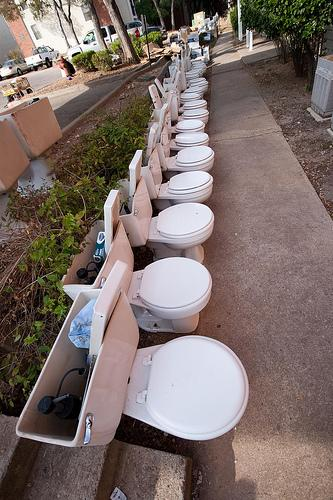Describe the image with the inclusion of specific details of the toilet setup. There are four toilets placed in a row with their seat covers down on a concrete surface, and the image showcases the plumbing, water tanks, and flush handles for each of the toilets. Express the content of the image, focusing on the positioning and intra-object relationships. Toilets with shut seat covers are arranged in a row on a concrete stage near a paved sidewalk, while various components such as trucks, buildings, and signs fill the background. Write a short narrative describing the scene in the image. In a public outdoor space, there is an unusual gathering of white toilets in a row. They are situated on a gray concrete foundation and surrounded by pavement, buildings, and vehicles. Describe the image, emphasizing the location of the toilets and notable objects in the background. White toilets with closed seat covers are positioned on a concrete area, backed by a paved sidewalk. Notable background objects include parked trucks, street signs, windows, and fire hydrants. Create a brief description of the image, highlighting the most prominent objects. The image features several toilets with seat covers down, placed on a concrete area with a paved sidewalk nearby, and a distant view of parked trucks, signs, and buildings. Mention the primary focus in the image, along with supplementary elements. The main focus is on multiple toilets that have their seat covers down. Supplementary components include sidewalks, vehicles and signs in the background. Narrate the scene in the image as a short story. The day started as unusual when John stumbled upon a row of white toilets with their seat covers down, sitting on a concrete area in his neighborhood. Intrigued, he noticed the quaint surroundings of the paved sidewalk, parked vehicles, and signs complementing the odd yet intriguing view. Explain the main features in the image, focusing on the toilets and their surroundings. The image shows several white toilets with closed seat covers on a concrete area. The surroundings include a paved sidewalk, a red light in distance, parked vehicles, and buildings. Write a description highlighting the situation in the image and its context. In a setting where one might not expect to find white toilets, these essential devices sit atop a concrete surface, their seat covers down, with a paved sidewalk, trucks, and buildings nearby. Describe the image and its components from a bird's eye perspective. From above, one would see a series of toilets with seat covers down, located on concrete with a nearby sidewalk, and the surrounding environment filled with vehicles, buildings, and signs. 